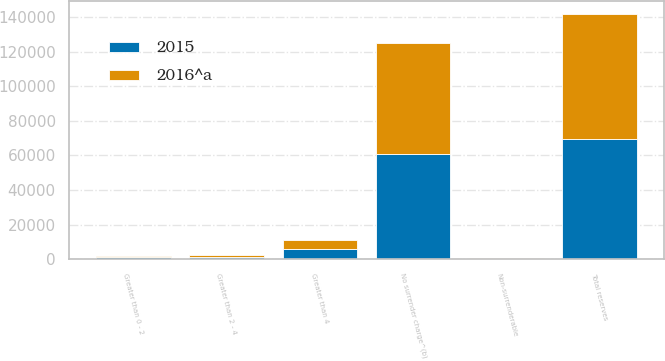Convert chart to OTSL. <chart><loc_0><loc_0><loc_500><loc_500><stacked_bar_chart><ecel><fcel>No surrender charge^(b)<fcel>Greater than 0 - 2<fcel>Greater than 2 - 4<fcel>Greater than 4<fcel>Non-surrenderable<fcel>Total reserves<nl><fcel>2016^a<fcel>64160<fcel>906<fcel>1395<fcel>5434<fcel>417<fcel>72312<nl><fcel>2015<fcel>60743<fcel>1200<fcel>1364<fcel>5955<fcel>360<fcel>69622<nl></chart> 